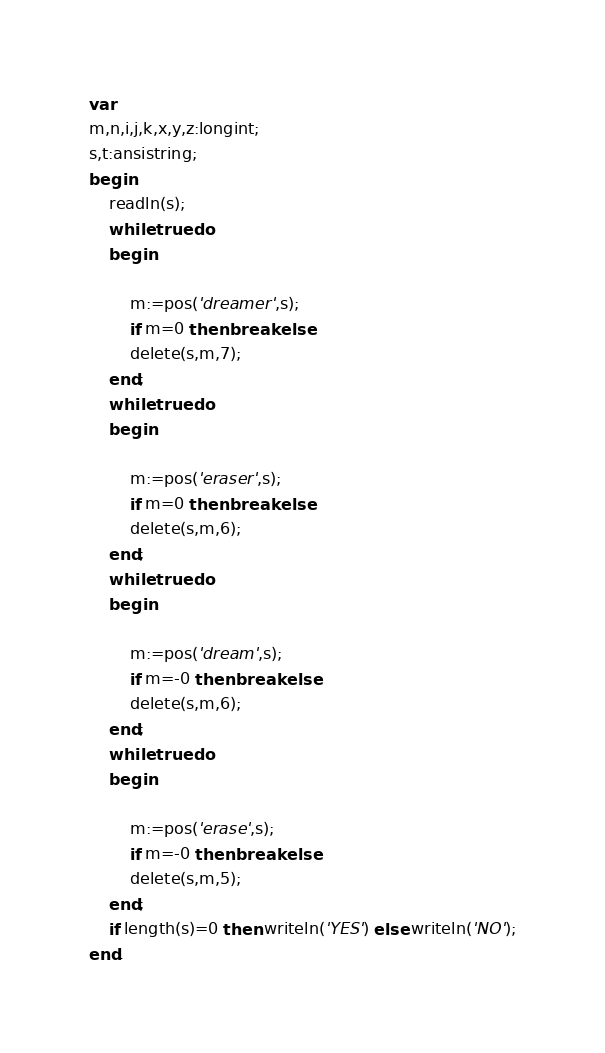<code> <loc_0><loc_0><loc_500><loc_500><_Pascal_>var
m,n,i,j,k,x,y,z:longint;
s,t:ansistring;
begin
    readln(s);
    while true do
    begin

        m:=pos('dreamer',s);
        if m=0 then break else
        delete(s,m,7);
    end;
    while true do
    begin

        m:=pos('eraser',s);
        if m=0 then break else
        delete(s,m,6);
    end;
    while true do
    begin

        m:=pos('dream',s);
        if m=-0 then break else
        delete(s,m,6);
    end;
    while true do
    begin

        m:=pos('erase',s);
        if m=-0 then break else
        delete(s,m,5);
    end;
    if length(s)=0 then writeln('YES') else writeln('NO');
end.</code> 